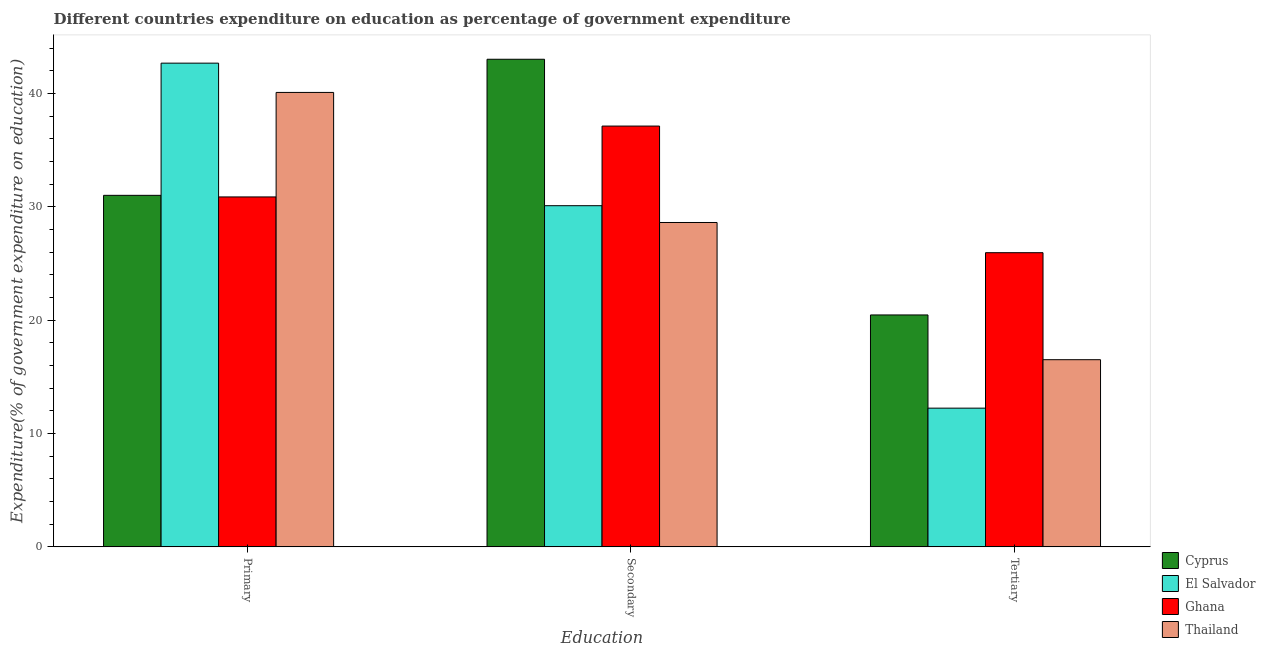How many groups of bars are there?
Give a very brief answer. 3. Are the number of bars per tick equal to the number of legend labels?
Keep it short and to the point. Yes. Are the number of bars on each tick of the X-axis equal?
Ensure brevity in your answer.  Yes. How many bars are there on the 3rd tick from the right?
Offer a terse response. 4. What is the label of the 3rd group of bars from the left?
Make the answer very short. Tertiary. What is the expenditure on secondary education in Ghana?
Provide a short and direct response. 37.12. Across all countries, what is the maximum expenditure on tertiary education?
Keep it short and to the point. 25.95. Across all countries, what is the minimum expenditure on secondary education?
Your answer should be very brief. 28.61. In which country was the expenditure on secondary education minimum?
Make the answer very short. Thailand. What is the total expenditure on primary education in the graph?
Provide a succinct answer. 144.63. What is the difference between the expenditure on primary education in El Salvador and that in Thailand?
Offer a terse response. 2.58. What is the difference between the expenditure on tertiary education in Ghana and the expenditure on primary education in Cyprus?
Your answer should be compact. -5.06. What is the average expenditure on primary education per country?
Your response must be concise. 36.16. What is the difference between the expenditure on secondary education and expenditure on primary education in Cyprus?
Make the answer very short. 12. In how many countries, is the expenditure on primary education greater than 10 %?
Your answer should be very brief. 4. What is the ratio of the expenditure on primary education in Thailand to that in El Salvador?
Keep it short and to the point. 0.94. What is the difference between the highest and the second highest expenditure on secondary education?
Your response must be concise. 5.89. What is the difference between the highest and the lowest expenditure on primary education?
Offer a terse response. 11.8. Is the sum of the expenditure on tertiary education in Cyprus and Thailand greater than the maximum expenditure on secondary education across all countries?
Keep it short and to the point. No. What does the 4th bar from the left in Tertiary represents?
Offer a very short reply. Thailand. What does the 3rd bar from the right in Secondary represents?
Your answer should be compact. El Salvador. What is the difference between two consecutive major ticks on the Y-axis?
Keep it short and to the point. 10. Are the values on the major ticks of Y-axis written in scientific E-notation?
Provide a succinct answer. No. Does the graph contain any zero values?
Offer a terse response. No. Where does the legend appear in the graph?
Provide a short and direct response. Bottom right. How are the legend labels stacked?
Provide a short and direct response. Vertical. What is the title of the graph?
Offer a terse response. Different countries expenditure on education as percentage of government expenditure. Does "Middle income" appear as one of the legend labels in the graph?
Ensure brevity in your answer.  No. What is the label or title of the X-axis?
Ensure brevity in your answer.  Education. What is the label or title of the Y-axis?
Your answer should be compact. Expenditure(% of government expenditure on education). What is the Expenditure(% of government expenditure on education) in Cyprus in Primary?
Your answer should be compact. 31.01. What is the Expenditure(% of government expenditure on education) in El Salvador in Primary?
Offer a terse response. 42.67. What is the Expenditure(% of government expenditure on education) of Ghana in Primary?
Offer a very short reply. 30.87. What is the Expenditure(% of government expenditure on education) of Thailand in Primary?
Provide a short and direct response. 40.08. What is the Expenditure(% of government expenditure on education) of Cyprus in Secondary?
Make the answer very short. 43.01. What is the Expenditure(% of government expenditure on education) of El Salvador in Secondary?
Provide a succinct answer. 30.09. What is the Expenditure(% of government expenditure on education) in Ghana in Secondary?
Provide a short and direct response. 37.12. What is the Expenditure(% of government expenditure on education) of Thailand in Secondary?
Your response must be concise. 28.61. What is the Expenditure(% of government expenditure on education) of Cyprus in Tertiary?
Keep it short and to the point. 20.46. What is the Expenditure(% of government expenditure on education) of El Salvador in Tertiary?
Keep it short and to the point. 12.24. What is the Expenditure(% of government expenditure on education) of Ghana in Tertiary?
Keep it short and to the point. 25.95. What is the Expenditure(% of government expenditure on education) in Thailand in Tertiary?
Ensure brevity in your answer.  16.51. Across all Education, what is the maximum Expenditure(% of government expenditure on education) in Cyprus?
Ensure brevity in your answer.  43.01. Across all Education, what is the maximum Expenditure(% of government expenditure on education) of El Salvador?
Your answer should be very brief. 42.67. Across all Education, what is the maximum Expenditure(% of government expenditure on education) in Ghana?
Offer a very short reply. 37.12. Across all Education, what is the maximum Expenditure(% of government expenditure on education) in Thailand?
Make the answer very short. 40.08. Across all Education, what is the minimum Expenditure(% of government expenditure on education) of Cyprus?
Offer a very short reply. 20.46. Across all Education, what is the minimum Expenditure(% of government expenditure on education) of El Salvador?
Give a very brief answer. 12.24. Across all Education, what is the minimum Expenditure(% of government expenditure on education) in Ghana?
Offer a very short reply. 25.95. Across all Education, what is the minimum Expenditure(% of government expenditure on education) of Thailand?
Provide a succinct answer. 16.51. What is the total Expenditure(% of government expenditure on education) of Cyprus in the graph?
Ensure brevity in your answer.  94.48. What is the total Expenditure(% of government expenditure on education) in El Salvador in the graph?
Make the answer very short. 85. What is the total Expenditure(% of government expenditure on education) in Ghana in the graph?
Ensure brevity in your answer.  93.93. What is the total Expenditure(% of government expenditure on education) of Thailand in the graph?
Provide a short and direct response. 85.21. What is the difference between the Expenditure(% of government expenditure on education) of Cyprus in Primary and that in Secondary?
Give a very brief answer. -12. What is the difference between the Expenditure(% of government expenditure on education) in El Salvador in Primary and that in Secondary?
Offer a terse response. 12.57. What is the difference between the Expenditure(% of government expenditure on education) of Ghana in Primary and that in Secondary?
Your answer should be compact. -6.25. What is the difference between the Expenditure(% of government expenditure on education) in Thailand in Primary and that in Secondary?
Provide a succinct answer. 11.47. What is the difference between the Expenditure(% of government expenditure on education) of Cyprus in Primary and that in Tertiary?
Your answer should be very brief. 10.55. What is the difference between the Expenditure(% of government expenditure on education) in El Salvador in Primary and that in Tertiary?
Provide a succinct answer. 30.43. What is the difference between the Expenditure(% of government expenditure on education) in Ghana in Primary and that in Tertiary?
Provide a succinct answer. 4.92. What is the difference between the Expenditure(% of government expenditure on education) of Thailand in Primary and that in Tertiary?
Keep it short and to the point. 23.58. What is the difference between the Expenditure(% of government expenditure on education) in Cyprus in Secondary and that in Tertiary?
Provide a succinct answer. 22.56. What is the difference between the Expenditure(% of government expenditure on education) in El Salvador in Secondary and that in Tertiary?
Offer a terse response. 17.86. What is the difference between the Expenditure(% of government expenditure on education) in Ghana in Secondary and that in Tertiary?
Your response must be concise. 11.17. What is the difference between the Expenditure(% of government expenditure on education) in Thailand in Secondary and that in Tertiary?
Your answer should be compact. 12.1. What is the difference between the Expenditure(% of government expenditure on education) of Cyprus in Primary and the Expenditure(% of government expenditure on education) of El Salvador in Secondary?
Ensure brevity in your answer.  0.91. What is the difference between the Expenditure(% of government expenditure on education) of Cyprus in Primary and the Expenditure(% of government expenditure on education) of Ghana in Secondary?
Provide a succinct answer. -6.11. What is the difference between the Expenditure(% of government expenditure on education) in Cyprus in Primary and the Expenditure(% of government expenditure on education) in Thailand in Secondary?
Keep it short and to the point. 2.4. What is the difference between the Expenditure(% of government expenditure on education) in El Salvador in Primary and the Expenditure(% of government expenditure on education) in Ghana in Secondary?
Offer a terse response. 5.55. What is the difference between the Expenditure(% of government expenditure on education) of El Salvador in Primary and the Expenditure(% of government expenditure on education) of Thailand in Secondary?
Your answer should be very brief. 14.06. What is the difference between the Expenditure(% of government expenditure on education) in Ghana in Primary and the Expenditure(% of government expenditure on education) in Thailand in Secondary?
Offer a very short reply. 2.25. What is the difference between the Expenditure(% of government expenditure on education) in Cyprus in Primary and the Expenditure(% of government expenditure on education) in El Salvador in Tertiary?
Your answer should be very brief. 18.77. What is the difference between the Expenditure(% of government expenditure on education) of Cyprus in Primary and the Expenditure(% of government expenditure on education) of Ghana in Tertiary?
Make the answer very short. 5.06. What is the difference between the Expenditure(% of government expenditure on education) in Cyprus in Primary and the Expenditure(% of government expenditure on education) in Thailand in Tertiary?
Give a very brief answer. 14.5. What is the difference between the Expenditure(% of government expenditure on education) of El Salvador in Primary and the Expenditure(% of government expenditure on education) of Ghana in Tertiary?
Your answer should be compact. 16.72. What is the difference between the Expenditure(% of government expenditure on education) in El Salvador in Primary and the Expenditure(% of government expenditure on education) in Thailand in Tertiary?
Your response must be concise. 26.16. What is the difference between the Expenditure(% of government expenditure on education) in Ghana in Primary and the Expenditure(% of government expenditure on education) in Thailand in Tertiary?
Ensure brevity in your answer.  14.36. What is the difference between the Expenditure(% of government expenditure on education) in Cyprus in Secondary and the Expenditure(% of government expenditure on education) in El Salvador in Tertiary?
Your response must be concise. 30.78. What is the difference between the Expenditure(% of government expenditure on education) of Cyprus in Secondary and the Expenditure(% of government expenditure on education) of Ghana in Tertiary?
Your response must be concise. 17.06. What is the difference between the Expenditure(% of government expenditure on education) of Cyprus in Secondary and the Expenditure(% of government expenditure on education) of Thailand in Tertiary?
Make the answer very short. 26.5. What is the difference between the Expenditure(% of government expenditure on education) of El Salvador in Secondary and the Expenditure(% of government expenditure on education) of Ghana in Tertiary?
Give a very brief answer. 4.15. What is the difference between the Expenditure(% of government expenditure on education) of El Salvador in Secondary and the Expenditure(% of government expenditure on education) of Thailand in Tertiary?
Give a very brief answer. 13.59. What is the difference between the Expenditure(% of government expenditure on education) in Ghana in Secondary and the Expenditure(% of government expenditure on education) in Thailand in Tertiary?
Offer a terse response. 20.61. What is the average Expenditure(% of government expenditure on education) of Cyprus per Education?
Offer a terse response. 31.49. What is the average Expenditure(% of government expenditure on education) of El Salvador per Education?
Offer a very short reply. 28.33. What is the average Expenditure(% of government expenditure on education) in Ghana per Education?
Offer a terse response. 31.31. What is the average Expenditure(% of government expenditure on education) in Thailand per Education?
Give a very brief answer. 28.4. What is the difference between the Expenditure(% of government expenditure on education) of Cyprus and Expenditure(% of government expenditure on education) of El Salvador in Primary?
Provide a succinct answer. -11.66. What is the difference between the Expenditure(% of government expenditure on education) in Cyprus and Expenditure(% of government expenditure on education) in Ghana in Primary?
Your response must be concise. 0.14. What is the difference between the Expenditure(% of government expenditure on education) in Cyprus and Expenditure(% of government expenditure on education) in Thailand in Primary?
Give a very brief answer. -9.08. What is the difference between the Expenditure(% of government expenditure on education) of El Salvador and Expenditure(% of government expenditure on education) of Ghana in Primary?
Your answer should be compact. 11.8. What is the difference between the Expenditure(% of government expenditure on education) of El Salvador and Expenditure(% of government expenditure on education) of Thailand in Primary?
Ensure brevity in your answer.  2.58. What is the difference between the Expenditure(% of government expenditure on education) of Ghana and Expenditure(% of government expenditure on education) of Thailand in Primary?
Your answer should be compact. -9.22. What is the difference between the Expenditure(% of government expenditure on education) of Cyprus and Expenditure(% of government expenditure on education) of El Salvador in Secondary?
Ensure brevity in your answer.  12.92. What is the difference between the Expenditure(% of government expenditure on education) in Cyprus and Expenditure(% of government expenditure on education) in Ghana in Secondary?
Your answer should be very brief. 5.89. What is the difference between the Expenditure(% of government expenditure on education) of Cyprus and Expenditure(% of government expenditure on education) of Thailand in Secondary?
Keep it short and to the point. 14.4. What is the difference between the Expenditure(% of government expenditure on education) of El Salvador and Expenditure(% of government expenditure on education) of Ghana in Secondary?
Give a very brief answer. -7.02. What is the difference between the Expenditure(% of government expenditure on education) of El Salvador and Expenditure(% of government expenditure on education) of Thailand in Secondary?
Provide a succinct answer. 1.48. What is the difference between the Expenditure(% of government expenditure on education) in Ghana and Expenditure(% of government expenditure on education) in Thailand in Secondary?
Your answer should be compact. 8.51. What is the difference between the Expenditure(% of government expenditure on education) in Cyprus and Expenditure(% of government expenditure on education) in El Salvador in Tertiary?
Make the answer very short. 8.22. What is the difference between the Expenditure(% of government expenditure on education) in Cyprus and Expenditure(% of government expenditure on education) in Ghana in Tertiary?
Provide a short and direct response. -5.49. What is the difference between the Expenditure(% of government expenditure on education) in Cyprus and Expenditure(% of government expenditure on education) in Thailand in Tertiary?
Your answer should be compact. 3.95. What is the difference between the Expenditure(% of government expenditure on education) of El Salvador and Expenditure(% of government expenditure on education) of Ghana in Tertiary?
Provide a succinct answer. -13.71. What is the difference between the Expenditure(% of government expenditure on education) of El Salvador and Expenditure(% of government expenditure on education) of Thailand in Tertiary?
Offer a terse response. -4.27. What is the difference between the Expenditure(% of government expenditure on education) in Ghana and Expenditure(% of government expenditure on education) in Thailand in Tertiary?
Give a very brief answer. 9.44. What is the ratio of the Expenditure(% of government expenditure on education) in Cyprus in Primary to that in Secondary?
Provide a short and direct response. 0.72. What is the ratio of the Expenditure(% of government expenditure on education) of El Salvador in Primary to that in Secondary?
Offer a terse response. 1.42. What is the ratio of the Expenditure(% of government expenditure on education) in Ghana in Primary to that in Secondary?
Your answer should be compact. 0.83. What is the ratio of the Expenditure(% of government expenditure on education) of Thailand in Primary to that in Secondary?
Offer a terse response. 1.4. What is the ratio of the Expenditure(% of government expenditure on education) of Cyprus in Primary to that in Tertiary?
Offer a terse response. 1.52. What is the ratio of the Expenditure(% of government expenditure on education) of El Salvador in Primary to that in Tertiary?
Ensure brevity in your answer.  3.49. What is the ratio of the Expenditure(% of government expenditure on education) in Ghana in Primary to that in Tertiary?
Your answer should be very brief. 1.19. What is the ratio of the Expenditure(% of government expenditure on education) of Thailand in Primary to that in Tertiary?
Your response must be concise. 2.43. What is the ratio of the Expenditure(% of government expenditure on education) in Cyprus in Secondary to that in Tertiary?
Offer a very short reply. 2.1. What is the ratio of the Expenditure(% of government expenditure on education) of El Salvador in Secondary to that in Tertiary?
Make the answer very short. 2.46. What is the ratio of the Expenditure(% of government expenditure on education) in Ghana in Secondary to that in Tertiary?
Provide a short and direct response. 1.43. What is the ratio of the Expenditure(% of government expenditure on education) of Thailand in Secondary to that in Tertiary?
Your answer should be very brief. 1.73. What is the difference between the highest and the second highest Expenditure(% of government expenditure on education) in Cyprus?
Keep it short and to the point. 12. What is the difference between the highest and the second highest Expenditure(% of government expenditure on education) of El Salvador?
Give a very brief answer. 12.57. What is the difference between the highest and the second highest Expenditure(% of government expenditure on education) of Ghana?
Give a very brief answer. 6.25. What is the difference between the highest and the second highest Expenditure(% of government expenditure on education) in Thailand?
Your answer should be very brief. 11.47. What is the difference between the highest and the lowest Expenditure(% of government expenditure on education) in Cyprus?
Make the answer very short. 22.56. What is the difference between the highest and the lowest Expenditure(% of government expenditure on education) of El Salvador?
Your response must be concise. 30.43. What is the difference between the highest and the lowest Expenditure(% of government expenditure on education) of Ghana?
Make the answer very short. 11.17. What is the difference between the highest and the lowest Expenditure(% of government expenditure on education) in Thailand?
Your answer should be compact. 23.58. 